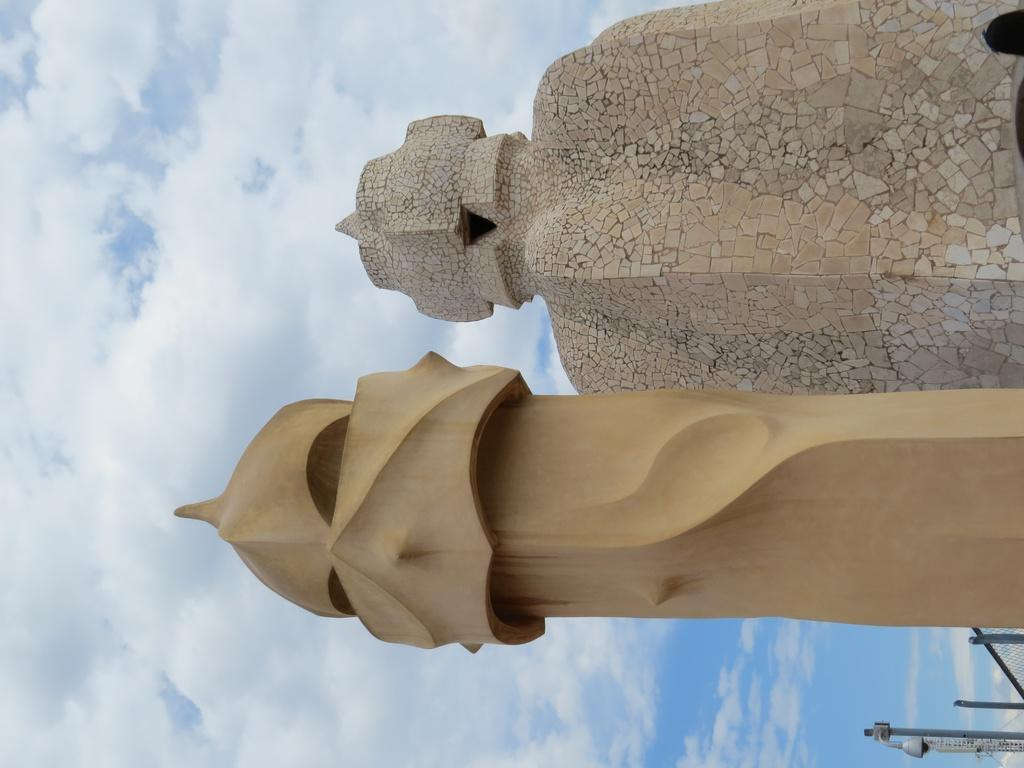What type of structures can be seen in the image? There are monuments in the image. What is visible in the background of the image? The sky is visible in the image. What can be observed in the sky? Clouds are present in the sky. What hobbies do the monuments enjoy in the image? Monuments do not have hobbies, as they are inanimate structures. 